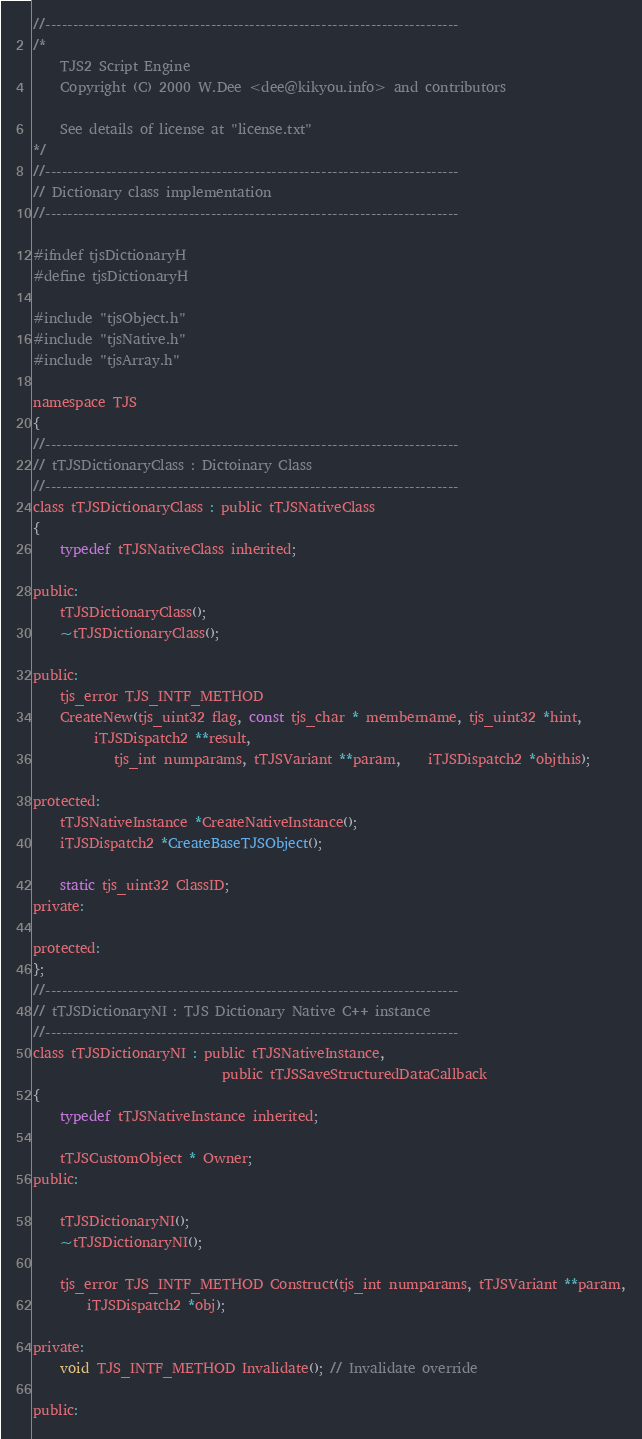Convert code to text. <code><loc_0><loc_0><loc_500><loc_500><_C_>//---------------------------------------------------------------------------
/*
	TJS2 Script Engine
	Copyright (C) 2000 W.Dee <dee@kikyou.info> and contributors

	See details of license at "license.txt"
*/
//---------------------------------------------------------------------------
// Dictionary class implementation
//---------------------------------------------------------------------------

#ifndef tjsDictionaryH
#define tjsDictionaryH

#include "tjsObject.h"
#include "tjsNative.h"
#include "tjsArray.h"

namespace TJS
{
//---------------------------------------------------------------------------
// tTJSDictionaryClass : Dictoinary Class
//---------------------------------------------------------------------------
class tTJSDictionaryClass : public tTJSNativeClass
{
	typedef tTJSNativeClass inherited;

public:
	tTJSDictionaryClass();
	~tTJSDictionaryClass();

public:
	tjs_error TJS_INTF_METHOD
	CreateNew(tjs_uint32 flag, const tjs_char * membername, tjs_uint32 *hint,
		 iTJSDispatch2 **result,
			tjs_int numparams, tTJSVariant **param,	iTJSDispatch2 *objthis);

protected:
	tTJSNativeInstance *CreateNativeInstance();
	iTJSDispatch2 *CreateBaseTJSObject();

	static tjs_uint32 ClassID;
private:

protected:
};
//---------------------------------------------------------------------------
// tTJSDictionaryNI : TJS Dictionary Native C++ instance
//---------------------------------------------------------------------------
class tTJSDictionaryNI : public tTJSNativeInstance,
							public tTJSSaveStructuredDataCallback
{
	typedef tTJSNativeInstance inherited;

	tTJSCustomObject * Owner;
public:

	tTJSDictionaryNI();
	~tTJSDictionaryNI();

	tjs_error TJS_INTF_METHOD Construct(tjs_int numparams, tTJSVariant **param,
		iTJSDispatch2 *obj);

private:
	void TJS_INTF_METHOD Invalidate(); // Invalidate override

public:</code> 